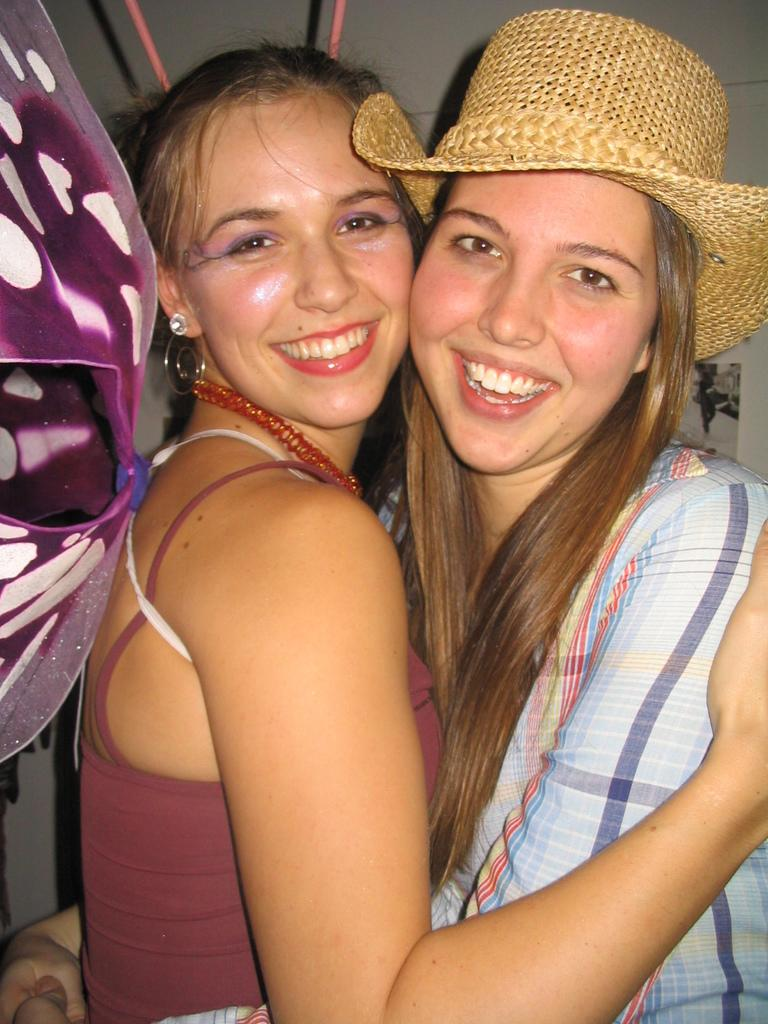How many women are in the image? There are two women in the image. What expressions do the women have? The women are smiling. What color object can be seen on the left side of the image? There is a violet color object on the left side of the image. What can be seen in the background of the image? There are two stick-like objects and a wall visible in the background of the image. What type of leather is being used to tell a story in the image? There is no leather or storytelling activity present in the image. What type of recess can be seen in the image? There is no recess visible in the image. 